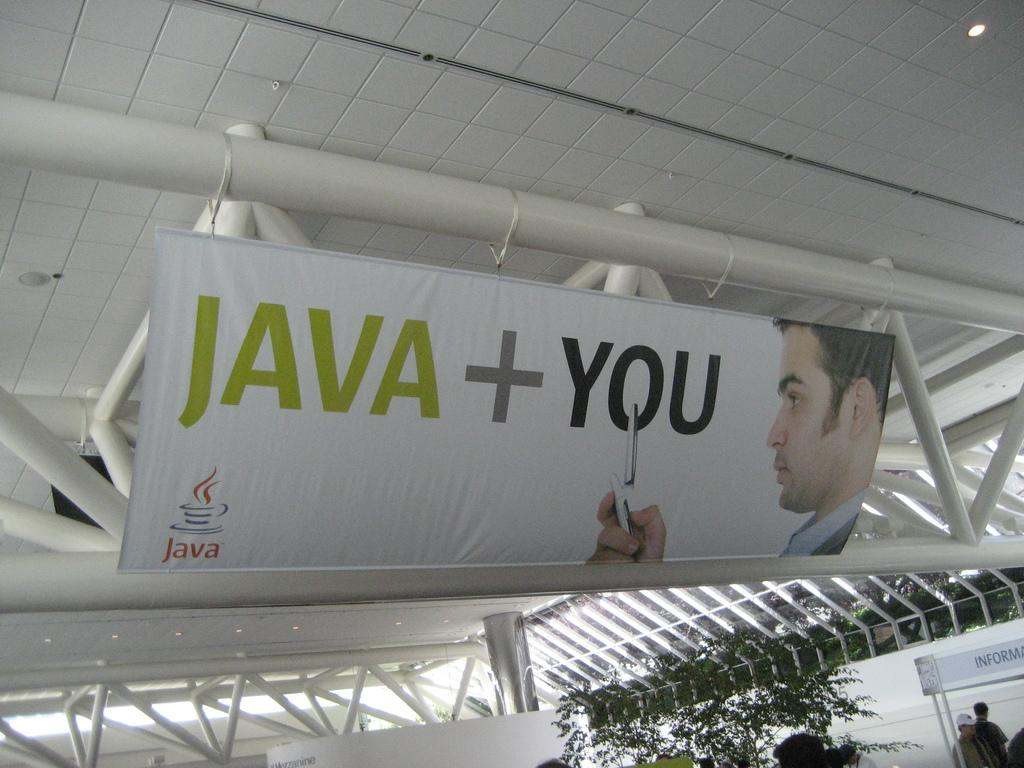<image>
Provide a brief description of the given image. A banner that says Java + You has a man with a flip phone on it. 